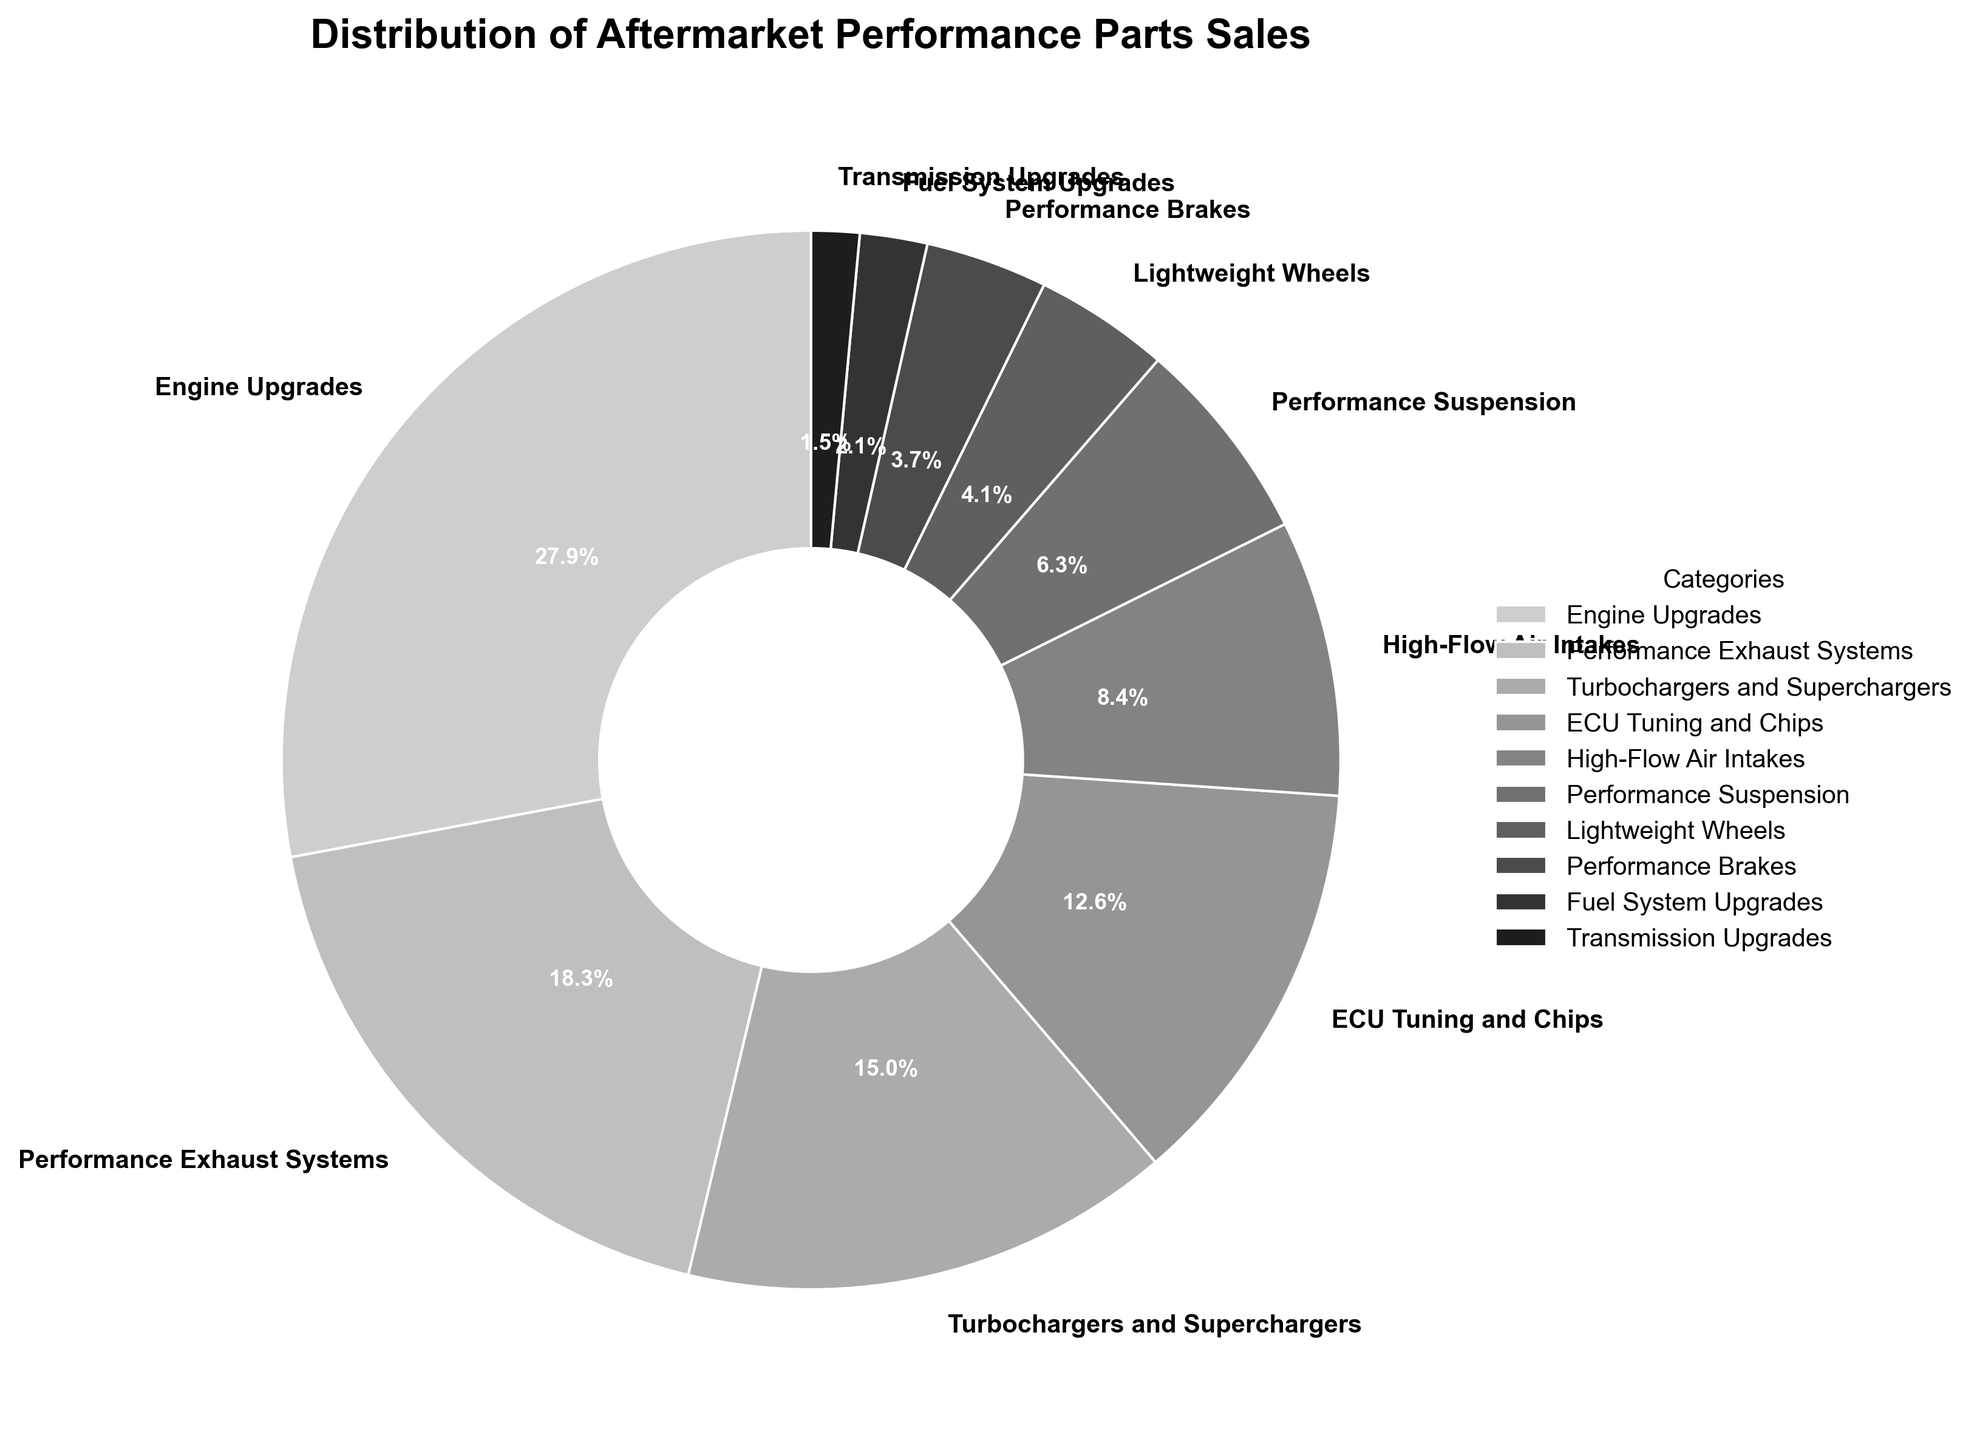Which category contributes the most to aftermarket performance parts sales? By looking at the percentages provided in the pie chart, the category with the highest percentage will have the largest slice. Here, 'Engine Upgrades' has the largest slice with 28.5%.
Answer: Engine Upgrades What is the combined percentage of sales for 'Turbochargers and Superchargers' and 'ECU Tuning and Chips'? Add the percentages of 'Turbochargers and Superchargers' and 'ECU Tuning and Chips': 15.3% + 12.9% = 28.2%.
Answer: 28.2% Which category has a larger share: 'High-Flow Air Intakes' or 'Performance Suspension'? By comparing the slices of the pie chart, 'High-Flow Air Intakes' has a larger percentage (8.6%) than 'Performance Suspension' (6.4%).
Answer: High-Flow Air Intakes How much larger is the share of 'Performance Exhaust Systems' compared to 'Lightweight Wheels'? Subtract the percentage of 'Lightweight Wheels' from 'Performance Exhaust Systems': 18.7% - 4.2% = 14.5%.
Answer: 14.5% What percentage of sales comes from 'Performance Brakes' and 'Fuel System Upgrades' combined? Add the percentages of 'Performance Brakes' and 'Fuel System Upgrades': 3.8% + 2.1% = 5.9%.
Answer: 5.9% Is the share of 'Transmission Upgrades' greater than 1.0%? By checking the percentage in the pie chart, 'Transmission Upgrades' has a slice representing 1.5%, which is greater than 1.0%.
Answer: Yes What is the difference in sales percentage between the category with the highest share and the one with the lowest share? Subtract the percentage of the category with the lowest share ('Transmission Upgrades' at 1.5%) from the highest share ('Engine Upgrades' at 28.5%): 28.5% - 1.5% = 27.0%.
Answer: 27.0% Which categories together contribute to over 50% of the sales? Add percentages starting from the highest until the total exceeds 50%. 'Engine Upgrades' (28.5%) + 'Performance Exhaust Systems' (18.7%) + 'Turbochargers and Superchargers' (15.3%) totals to 62.5%, so these three categories together exceed 50%.
Answer: Engine Upgrades, Performance Exhaust Systems, and Turbochargers and Superchargers 